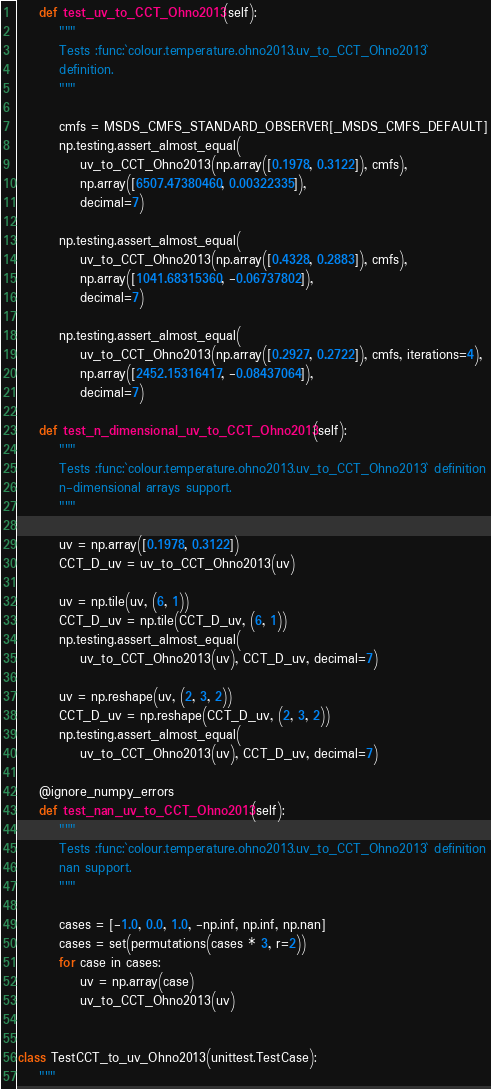Convert code to text. <code><loc_0><loc_0><loc_500><loc_500><_Python_>
    def test_uv_to_CCT_Ohno2013(self):
        """
        Tests :func:`colour.temperature.ohno2013.uv_to_CCT_Ohno2013`
        definition.
        """

        cmfs = MSDS_CMFS_STANDARD_OBSERVER[_MSDS_CMFS_DEFAULT]
        np.testing.assert_almost_equal(
            uv_to_CCT_Ohno2013(np.array([0.1978, 0.3122]), cmfs),
            np.array([6507.47380460, 0.00322335]),
            decimal=7)

        np.testing.assert_almost_equal(
            uv_to_CCT_Ohno2013(np.array([0.4328, 0.2883]), cmfs),
            np.array([1041.68315360, -0.06737802]),
            decimal=7)

        np.testing.assert_almost_equal(
            uv_to_CCT_Ohno2013(np.array([0.2927, 0.2722]), cmfs, iterations=4),
            np.array([2452.15316417, -0.08437064]),
            decimal=7)

    def test_n_dimensional_uv_to_CCT_Ohno2013(self):
        """
        Tests :func:`colour.temperature.ohno2013.uv_to_CCT_Ohno2013` definition
        n-dimensional arrays support.
        """

        uv = np.array([0.1978, 0.3122])
        CCT_D_uv = uv_to_CCT_Ohno2013(uv)

        uv = np.tile(uv, (6, 1))
        CCT_D_uv = np.tile(CCT_D_uv, (6, 1))
        np.testing.assert_almost_equal(
            uv_to_CCT_Ohno2013(uv), CCT_D_uv, decimal=7)

        uv = np.reshape(uv, (2, 3, 2))
        CCT_D_uv = np.reshape(CCT_D_uv, (2, 3, 2))
        np.testing.assert_almost_equal(
            uv_to_CCT_Ohno2013(uv), CCT_D_uv, decimal=7)

    @ignore_numpy_errors
    def test_nan_uv_to_CCT_Ohno2013(self):
        """
        Tests :func:`colour.temperature.ohno2013.uv_to_CCT_Ohno2013` definition
        nan support.
        """

        cases = [-1.0, 0.0, 1.0, -np.inf, np.inf, np.nan]
        cases = set(permutations(cases * 3, r=2))
        for case in cases:
            uv = np.array(case)
            uv_to_CCT_Ohno2013(uv)


class TestCCT_to_uv_Ohno2013(unittest.TestCase):
    """</code> 